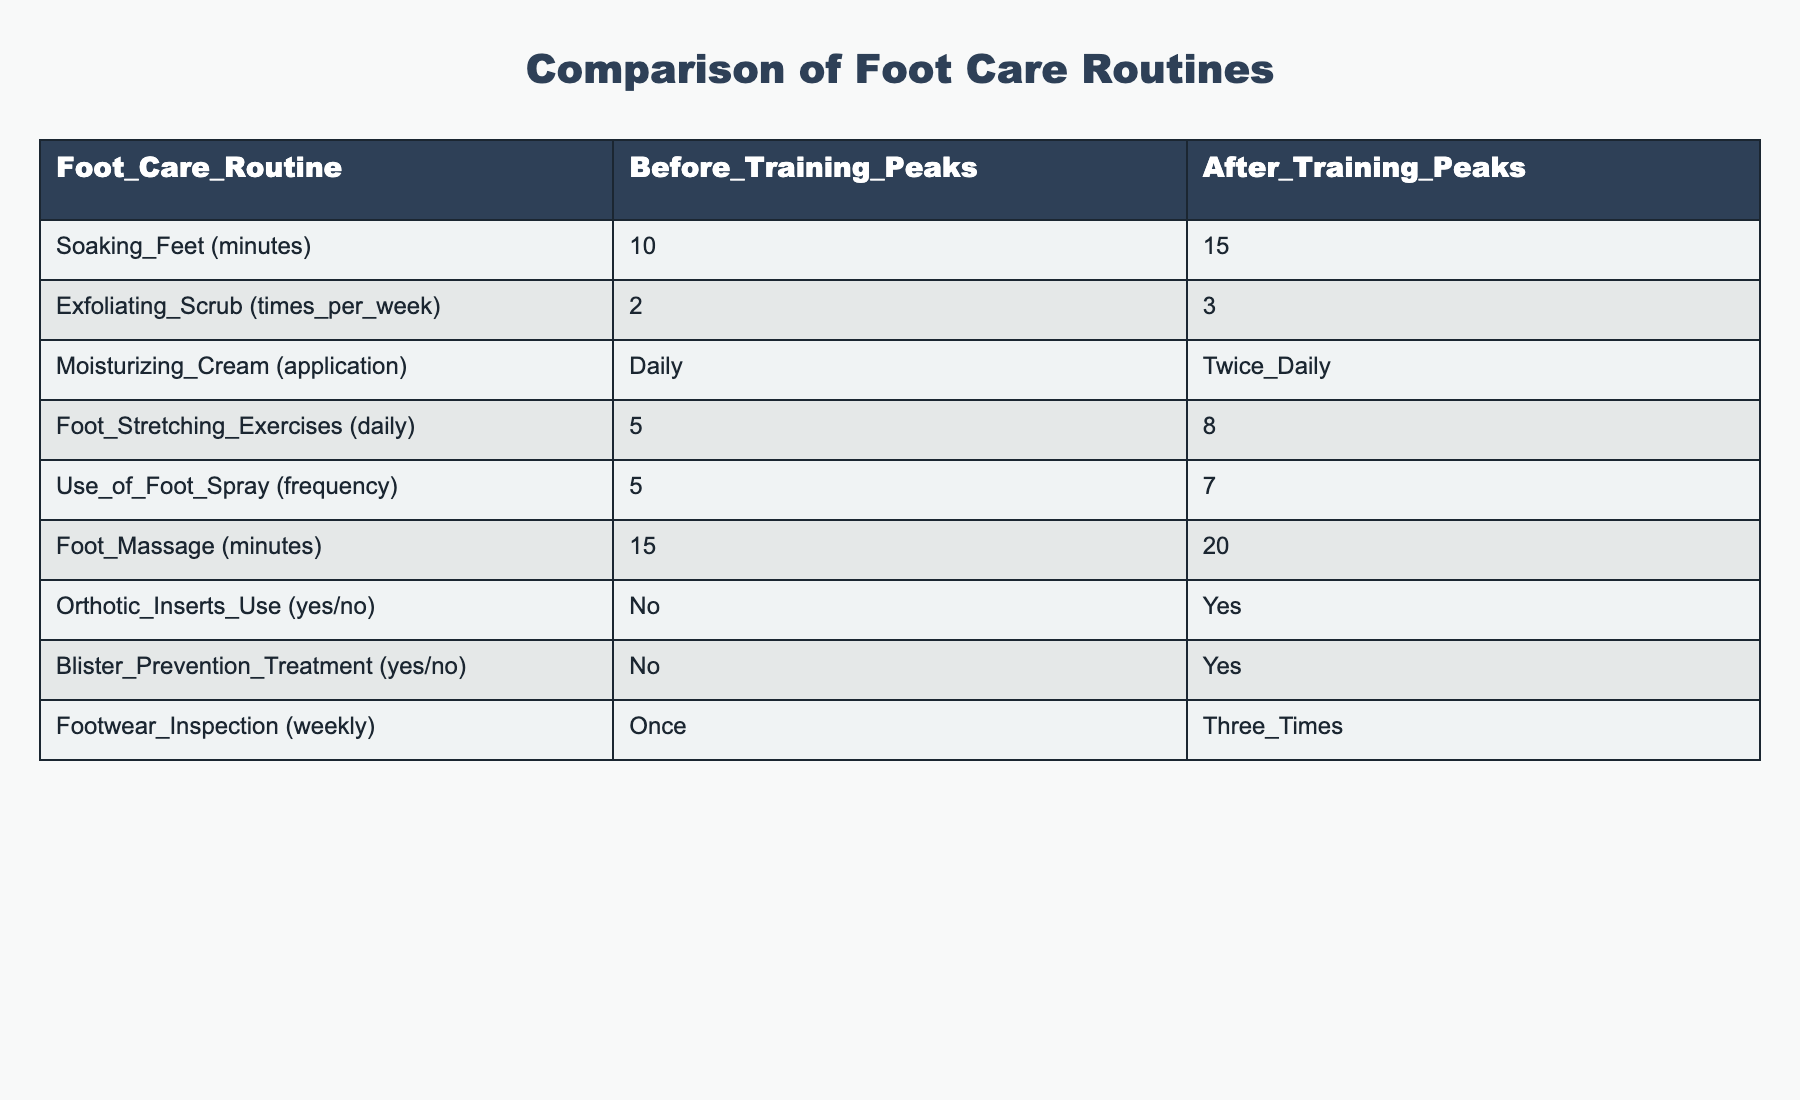What is the soaking time for feet before training peaks? The table indicates that the soaking time is listed as 10 minutes before training peaks.
Answer: 10 minutes How many times per week is the exfoliating scrub used after training peaks? According to the table, the exfoliating scrub is applied 3 times per week after training peaks.
Answer: 3 times Is there an increase in the frequency of using foot spray after training peaks compared to before? Yes, the table shows an increase from 5 times before training peaks to 7 times after.
Answer: Yes What is the total increase in foot stretching exercises from before to after training peaks? Before training peaks, foot stretching exercises are done 5 times daily, which increases to 8 times daily after training peaks. The total increase is 8 - 5 = 3.
Answer: 3 How frequently is blister prevention treatment used after training peaks? The table shows that blister prevention treatment is used, as indicated by 'Yes,' after training peaks.
Answer: Yes What is the difference in foot massage time per week before and after training peaks? Before training peaks, the foot massage time is 15 minutes, which increases to 20 minutes after training peaks. The difference is 20 - 15 = 5 minutes.
Answer: 5 minutes Has the use of orthotic inserts increased from before to after training peaks? Yes, before training peaks orthotic inserts were not used ('No'), but after they are used ('Yes').
Answer: Yes What is the total number of times foot inspections are carried out weekly before training peaks? The table states that footwear inspection occurs once a week before training peaks.
Answer: Once How does the number of daily foot stretching exercises compare before and after training peaks? Before training peaks, 5 exercises were practiced daily, and this increased to 8 after training peaks, indicating an increase of 3 exercises.
Answer: Increase of 3 exercises What is the average foot care routine duration for soaking, massage, and stretching before training peaks? The durations for soaking (10 minutes), massage (15 minutes), and stretching (5 minutes) total 10 + 15 + 5 = 30 minutes. The average is 30/3 = 10 minutes.
Answer: 10 minutes 